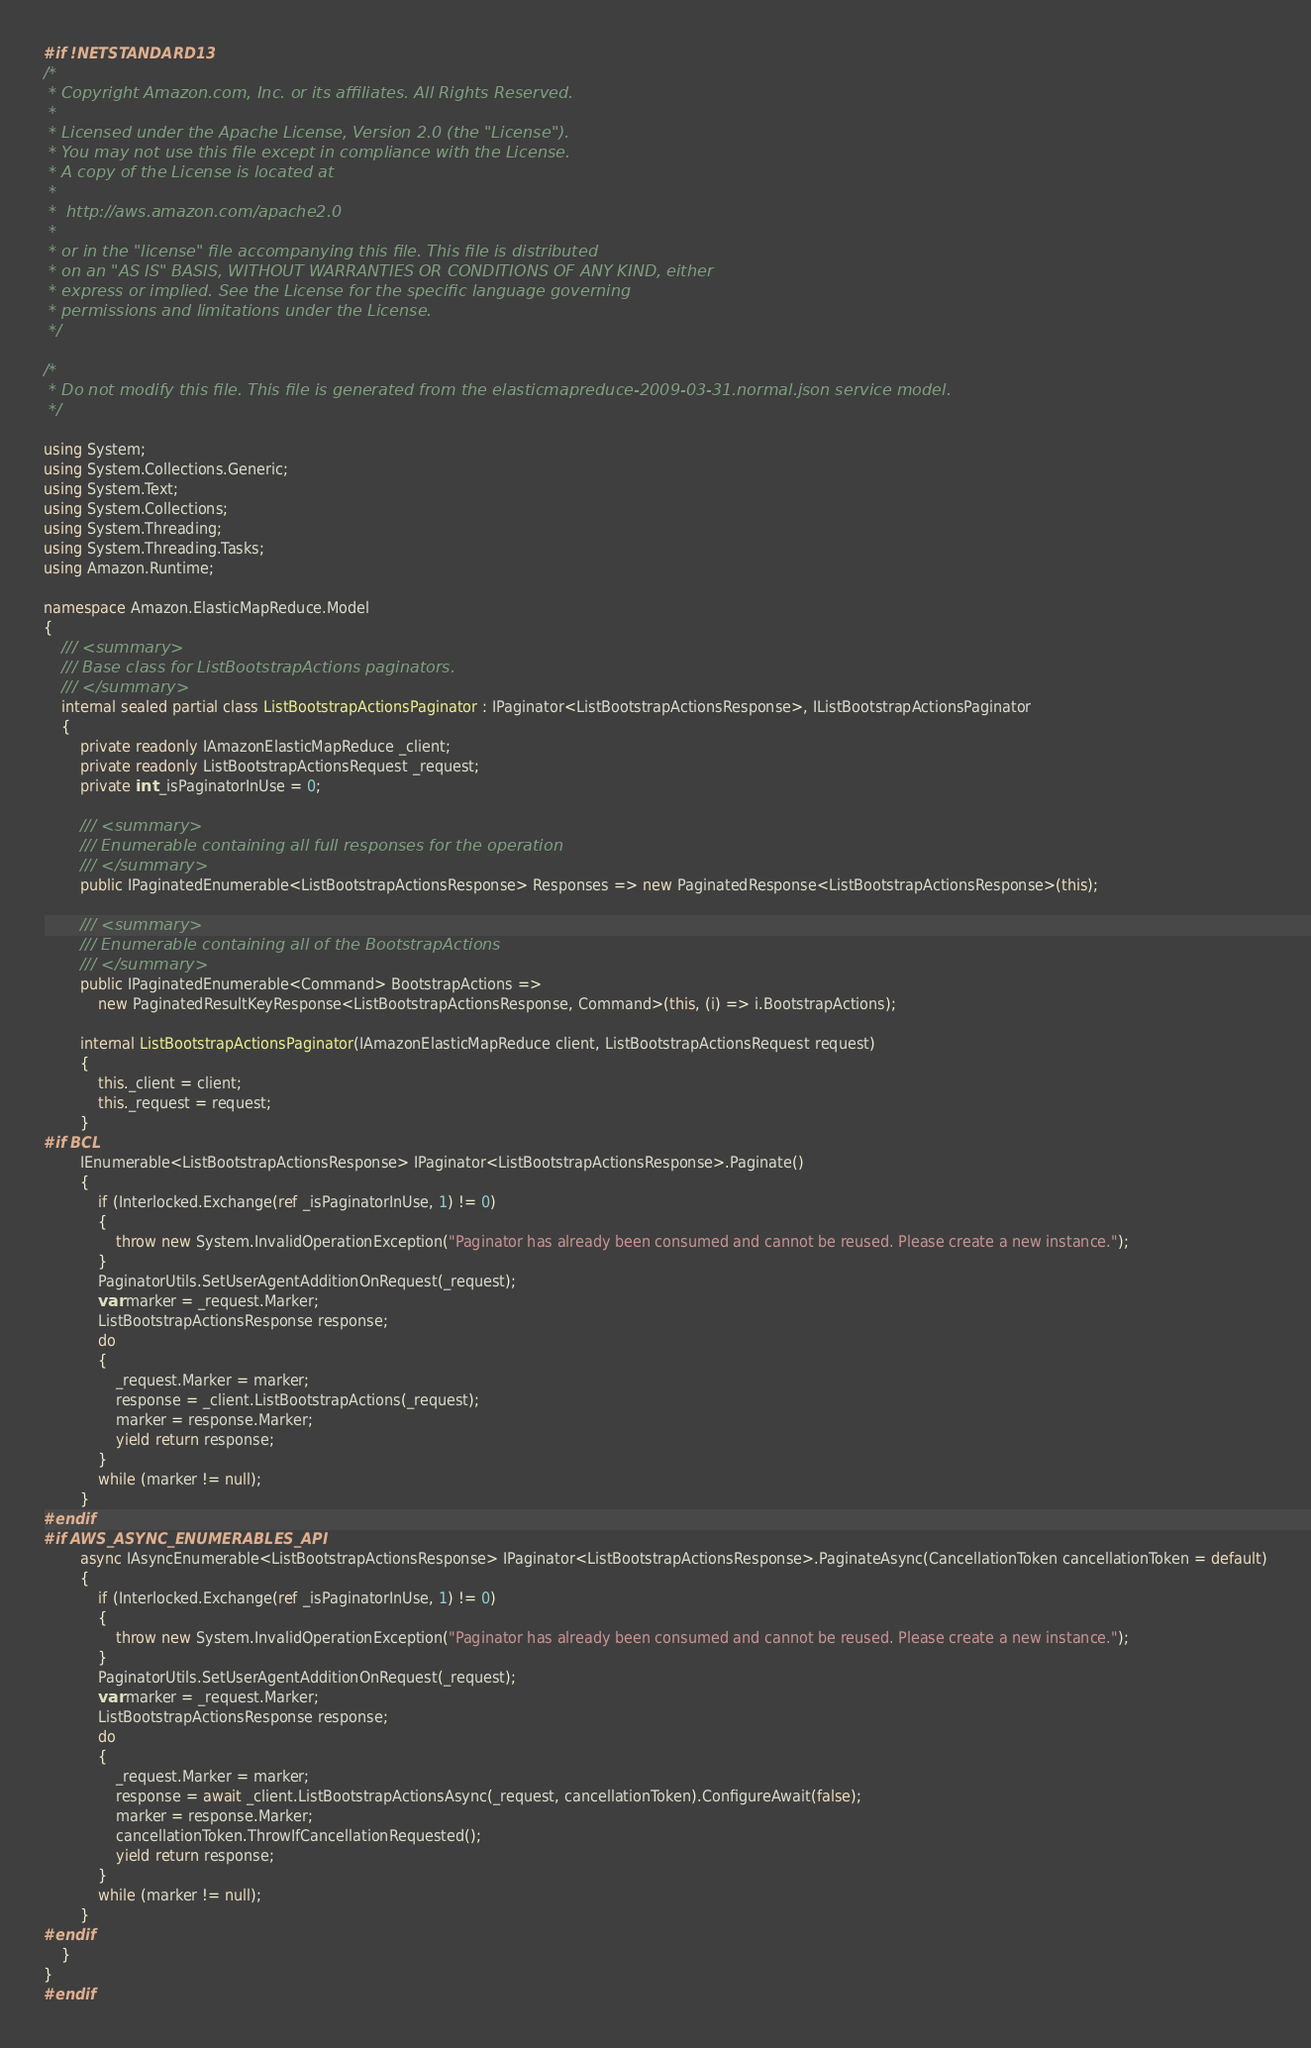Convert code to text. <code><loc_0><loc_0><loc_500><loc_500><_C#_>#if !NETSTANDARD13
/*
 * Copyright Amazon.com, Inc. or its affiliates. All Rights Reserved.
 * 
 * Licensed under the Apache License, Version 2.0 (the "License").
 * You may not use this file except in compliance with the License.
 * A copy of the License is located at
 * 
 *  http://aws.amazon.com/apache2.0
 * 
 * or in the "license" file accompanying this file. This file is distributed
 * on an "AS IS" BASIS, WITHOUT WARRANTIES OR CONDITIONS OF ANY KIND, either
 * express or implied. See the License for the specific language governing
 * permissions and limitations under the License.
 */

/*
 * Do not modify this file. This file is generated from the elasticmapreduce-2009-03-31.normal.json service model.
 */

using System;
using System.Collections.Generic;
using System.Text;
using System.Collections;
using System.Threading;
using System.Threading.Tasks;
using Amazon.Runtime;
 
namespace Amazon.ElasticMapReduce.Model
{
    /// <summary>
    /// Base class for ListBootstrapActions paginators.
    /// </summary>
    internal sealed partial class ListBootstrapActionsPaginator : IPaginator<ListBootstrapActionsResponse>, IListBootstrapActionsPaginator
    {
        private readonly IAmazonElasticMapReduce _client;
        private readonly ListBootstrapActionsRequest _request;
        private int _isPaginatorInUse = 0;
        
        /// <summary>
        /// Enumerable containing all full responses for the operation
        /// </summary>
        public IPaginatedEnumerable<ListBootstrapActionsResponse> Responses => new PaginatedResponse<ListBootstrapActionsResponse>(this);

        /// <summary>
        /// Enumerable containing all of the BootstrapActions
        /// </summary>
        public IPaginatedEnumerable<Command> BootstrapActions => 
            new PaginatedResultKeyResponse<ListBootstrapActionsResponse, Command>(this, (i) => i.BootstrapActions);

        internal ListBootstrapActionsPaginator(IAmazonElasticMapReduce client, ListBootstrapActionsRequest request)
        {
            this._client = client;
            this._request = request;
        }
#if BCL
        IEnumerable<ListBootstrapActionsResponse> IPaginator<ListBootstrapActionsResponse>.Paginate()
        {
            if (Interlocked.Exchange(ref _isPaginatorInUse, 1) != 0)
            {
                throw new System.InvalidOperationException("Paginator has already been consumed and cannot be reused. Please create a new instance.");
            }
            PaginatorUtils.SetUserAgentAdditionOnRequest(_request);
            var marker = _request.Marker;
            ListBootstrapActionsResponse response;
            do
            {
                _request.Marker = marker;
                response = _client.ListBootstrapActions(_request);
                marker = response.Marker;
                yield return response;
            }
            while (marker != null);
        }
#endif
#if AWS_ASYNC_ENUMERABLES_API
        async IAsyncEnumerable<ListBootstrapActionsResponse> IPaginator<ListBootstrapActionsResponse>.PaginateAsync(CancellationToken cancellationToken = default)
        {
            if (Interlocked.Exchange(ref _isPaginatorInUse, 1) != 0)
            {
                throw new System.InvalidOperationException("Paginator has already been consumed and cannot be reused. Please create a new instance.");
            }
            PaginatorUtils.SetUserAgentAdditionOnRequest(_request);
            var marker = _request.Marker;
            ListBootstrapActionsResponse response;
            do
            {
                _request.Marker = marker;
                response = await _client.ListBootstrapActionsAsync(_request, cancellationToken).ConfigureAwait(false);
                marker = response.Marker;
                cancellationToken.ThrowIfCancellationRequested();
                yield return response;
            }
            while (marker != null);
        }
#endif
    }
}
#endif</code> 